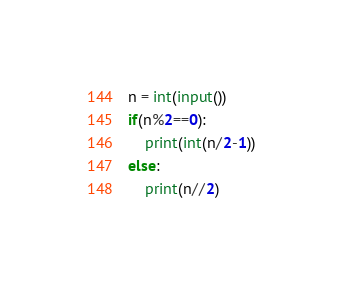Convert code to text. <code><loc_0><loc_0><loc_500><loc_500><_Python_>n = int(input())
if(n%2==0):
    print(int(n/2-1))
else:
    print(n//2)</code> 